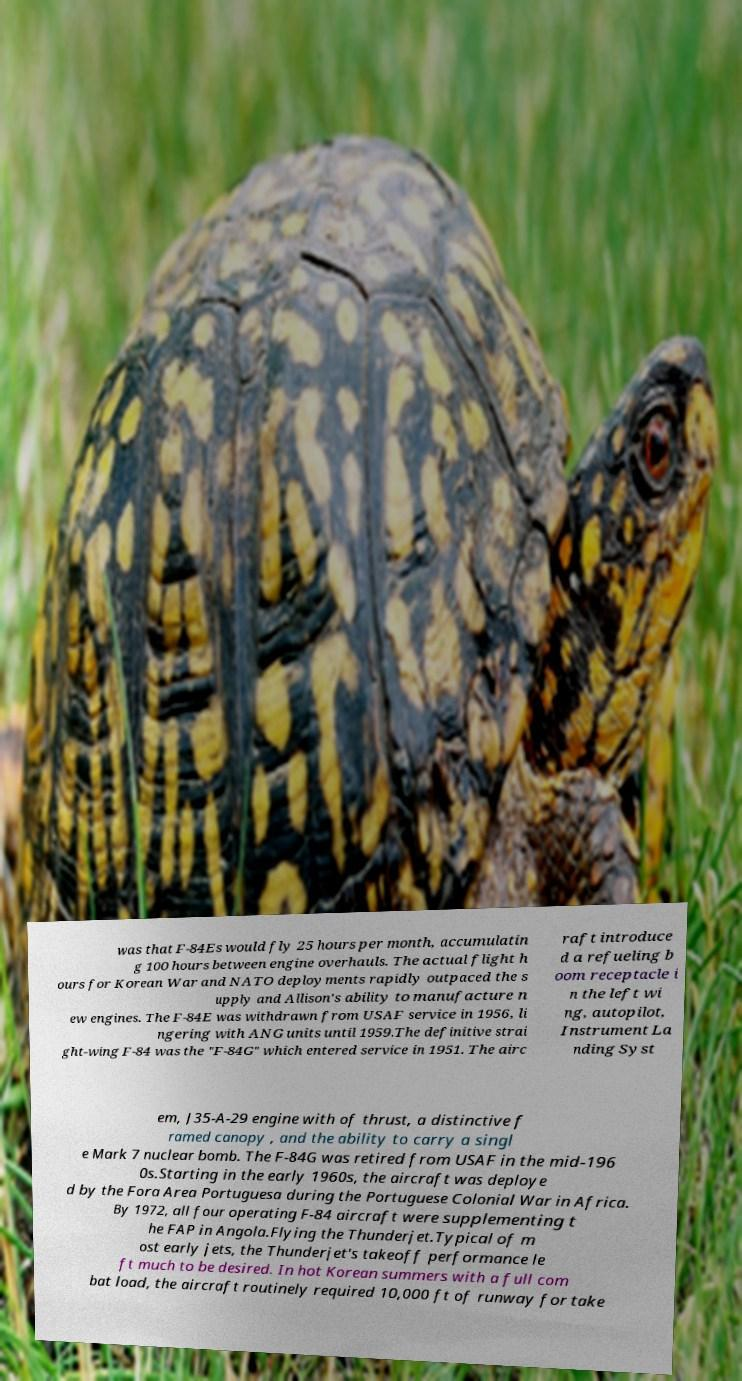What messages or text are displayed in this image? I need them in a readable, typed format. was that F-84Es would fly 25 hours per month, accumulatin g 100 hours between engine overhauls. The actual flight h ours for Korean War and NATO deployments rapidly outpaced the s upply and Allison's ability to manufacture n ew engines. The F-84E was withdrawn from USAF service in 1956, li ngering with ANG units until 1959.The definitive strai ght-wing F-84 was the "F-84G" which entered service in 1951. The airc raft introduce d a refueling b oom receptacle i n the left wi ng, autopilot, Instrument La nding Syst em, J35-A-29 engine with of thrust, a distinctive f ramed canopy , and the ability to carry a singl e Mark 7 nuclear bomb. The F-84G was retired from USAF in the mid-196 0s.Starting in the early 1960s, the aircraft was deploye d by the Fora Area Portuguesa during the Portuguese Colonial War in Africa. By 1972, all four operating F-84 aircraft were supplementing t he FAP in Angola.Flying the Thunderjet.Typical of m ost early jets, the Thunderjet's takeoff performance le ft much to be desired. In hot Korean summers with a full com bat load, the aircraft routinely required 10,000 ft of runway for take 